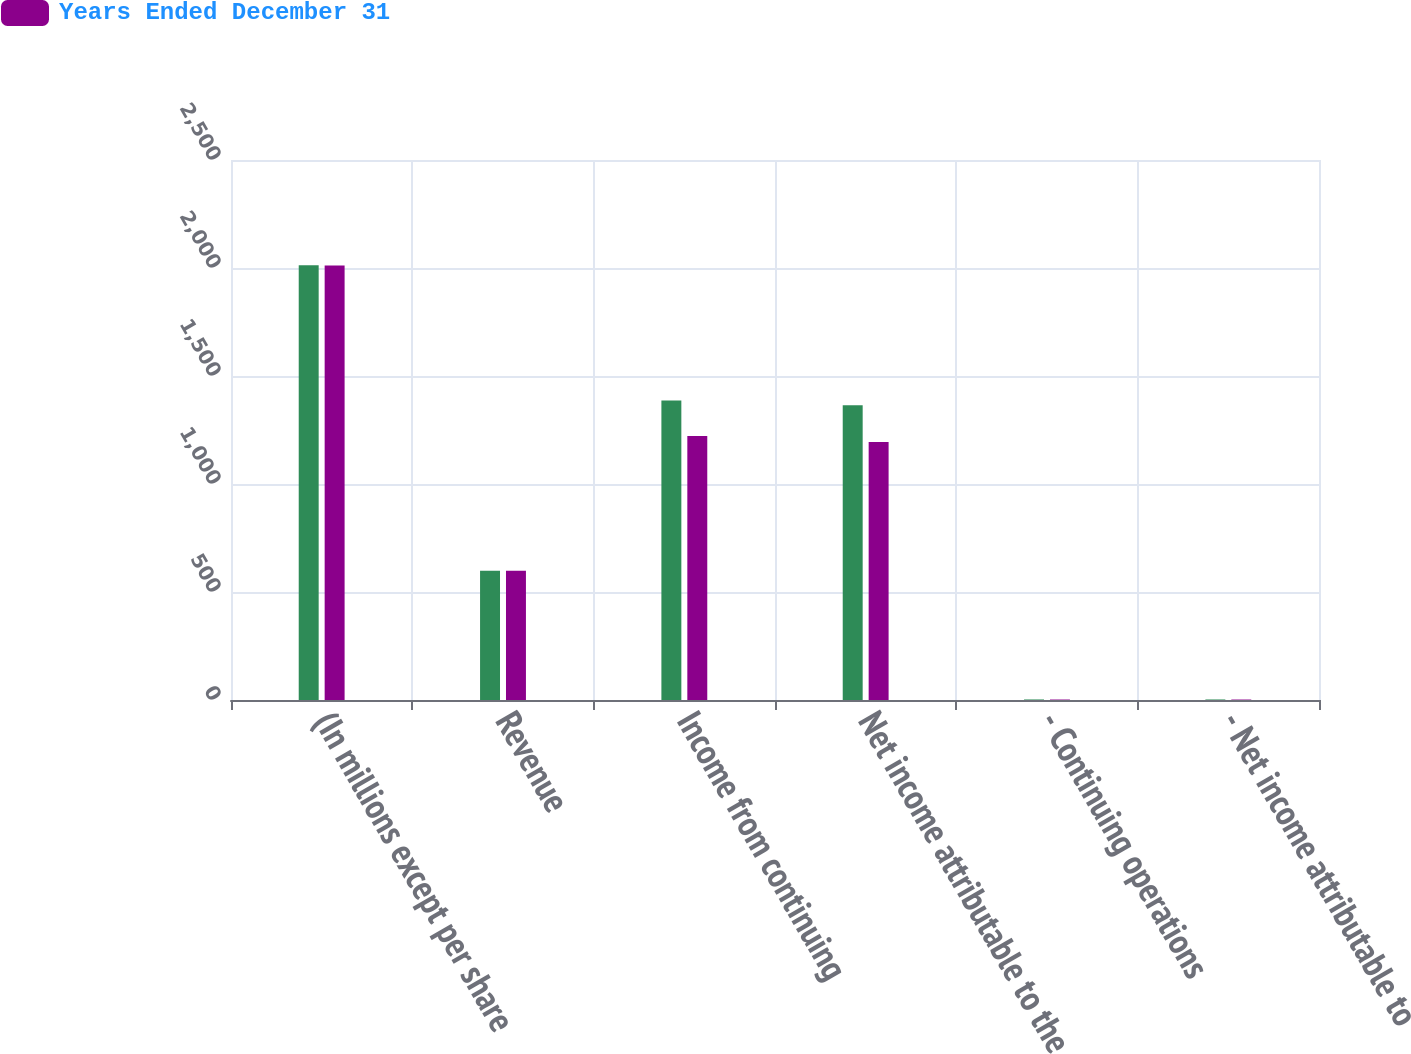Convert chart. <chart><loc_0><loc_0><loc_500><loc_500><stacked_bar_chart><ecel><fcel>(In millions except per share<fcel>Revenue<fcel>Income from continuing<fcel>Net income attributable to the<fcel>- Continuing operations<fcel>- Net income attributable to<nl><fcel>nan<fcel>2013<fcel>598.745<fcel>1387<fcel>1365<fcel>2.48<fcel>2.45<nl><fcel>Years Ended December 31<fcel>2012<fcel>598.745<fcel>1222<fcel>1195<fcel>2.2<fcel>2.16<nl></chart> 